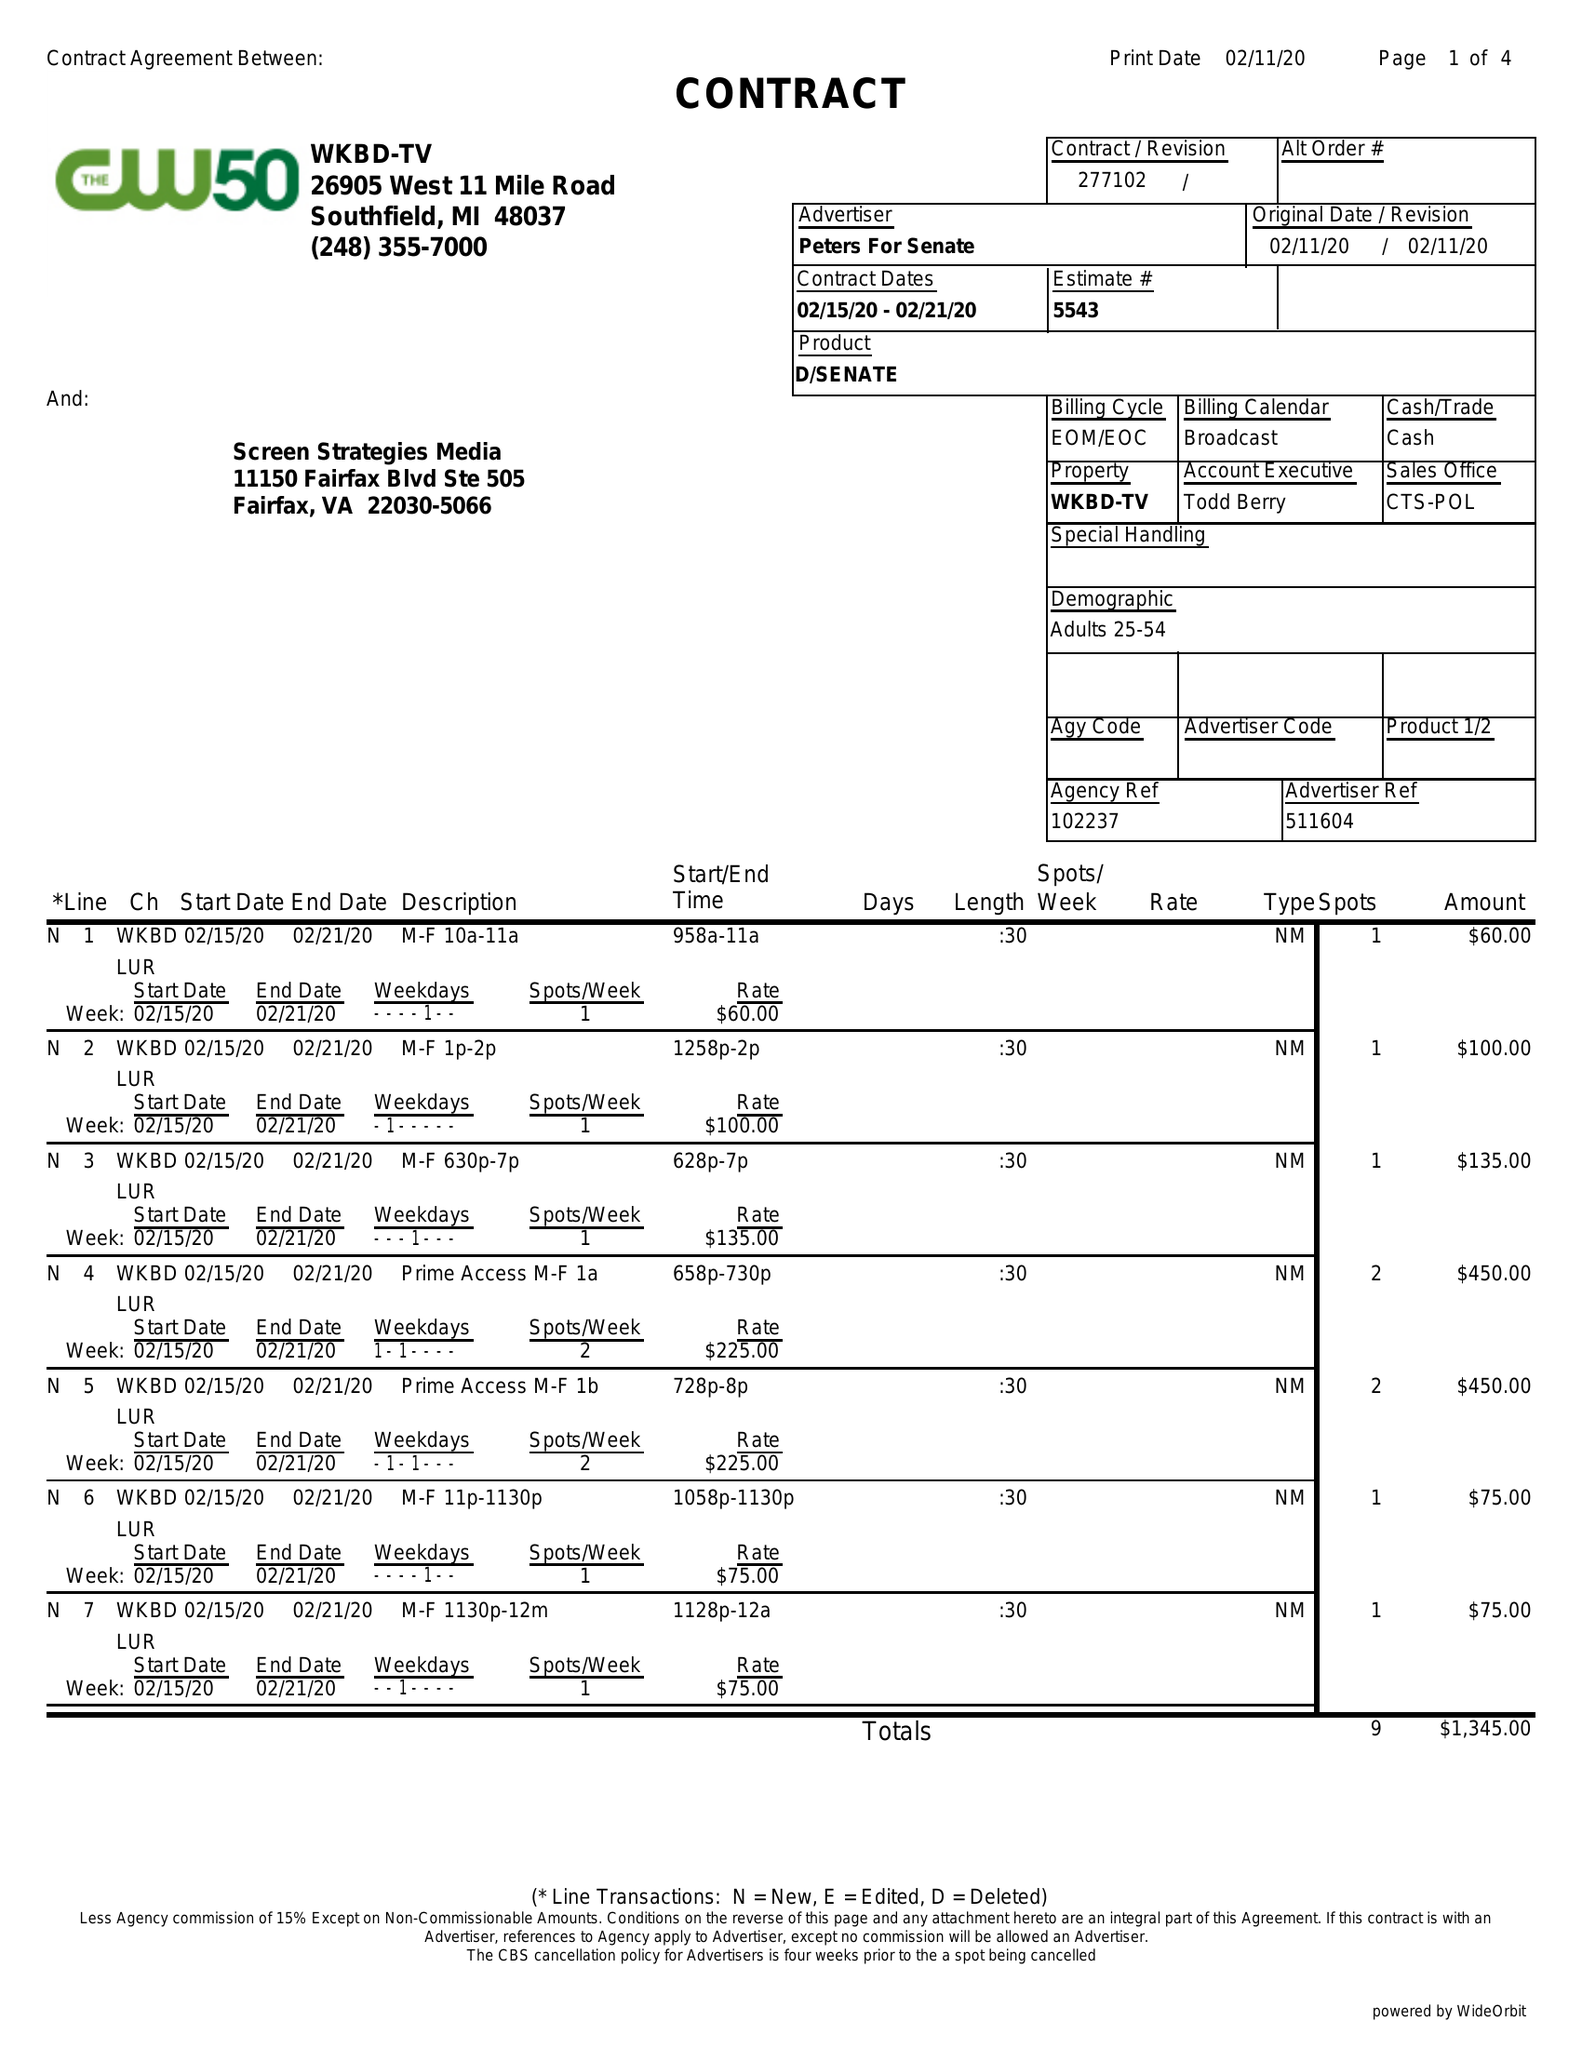What is the value for the gross_amount?
Answer the question using a single word or phrase. 1345.00 